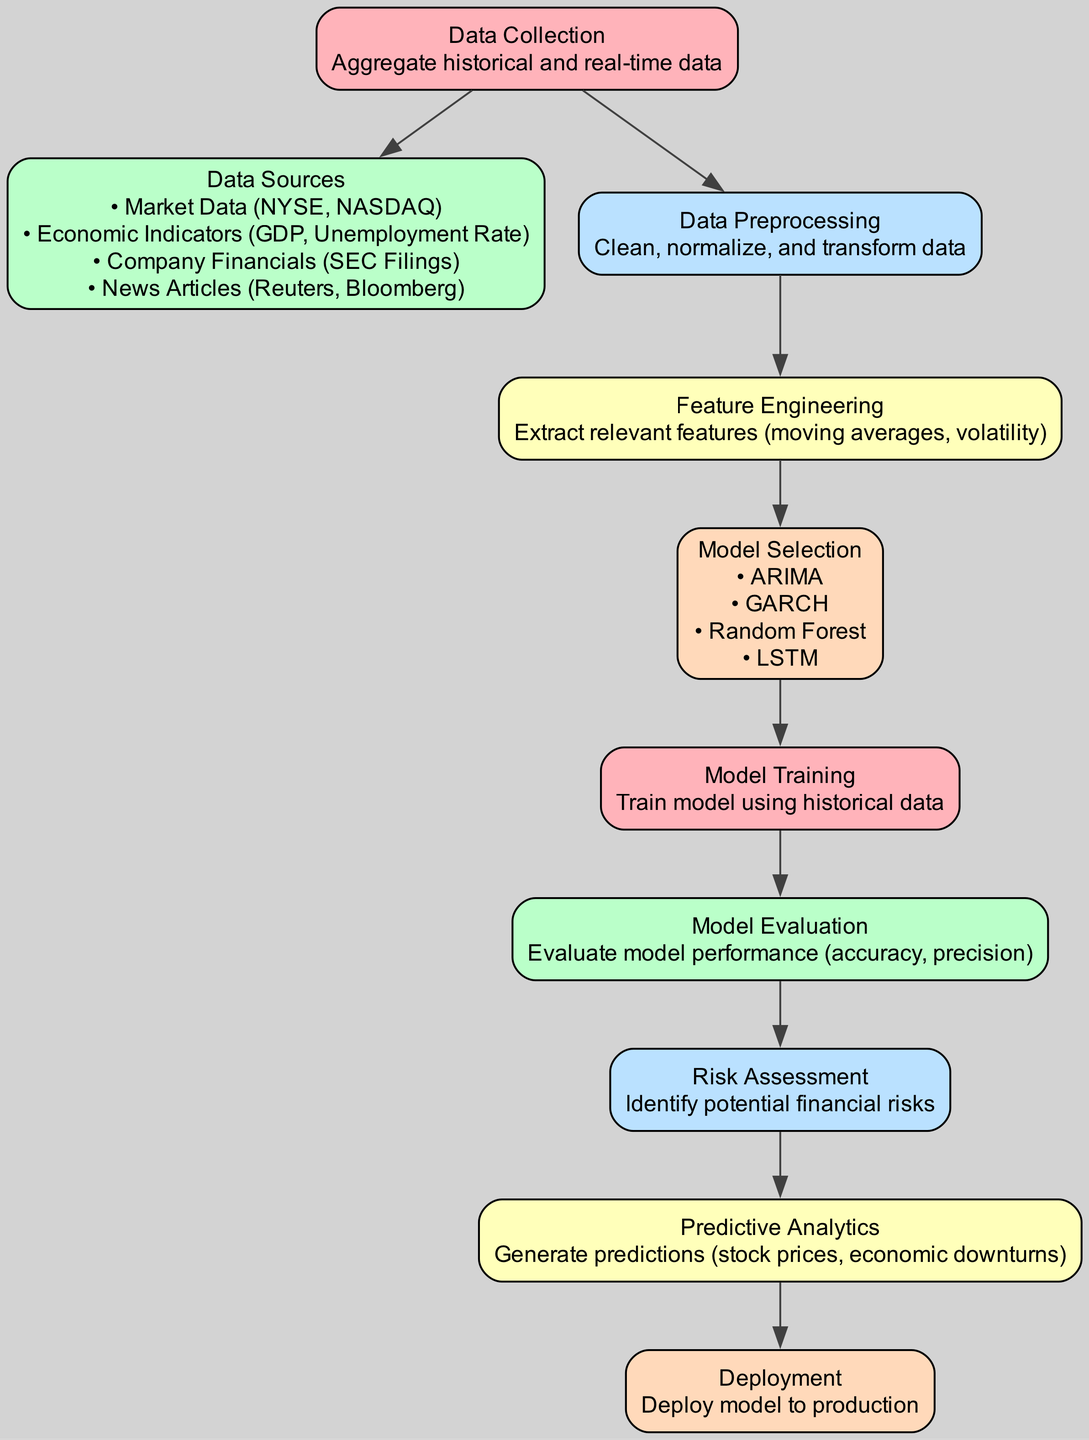What is the first step in the predictive analytics process? The diagram indicates that "Data Collection" is the starting node. This is the first step where historical and real-time data is aggregated.
Answer: Data Collection How many edges are present in the diagram? The diagram shows a total of 9 edges connecting the nodes. Each edge represents a relationship between steps in the predictive analytics process.
Answer: 9 What nodes are linked directly to "Data Preprocessing"? From the diagram, "Data Preprocessing" has direct edges leading to "Feature Engineering" and "Data Collection." This indicates its relationship with both the prior step and the next step.
Answer: Feature Engineering, Data Collection Which model selection techniques are mentioned in the diagram? The diagram highlights four model selection techniques: ARIMA, GARCH, Random Forest, and LSTM. These models are essential for making predictions based on the data.
Answer: ARIMA, GARCH, Random Forest, LSTM What is produced as a result of the "Risk Assessment" stage? The diagram shows that "Risk Assessment" leads to "Predictive Analytics." This indicates that the identification of potential financial risks is a precursor to making predictions.
Answer: Predictive Analytics What comes after "Model Evaluation" in the process? According to the diagram, "Risk Assessment" follows "Model Evaluation." This indicates that evaluating the model's performance directly informs the assessment of risk.
Answer: Risk Assessment Which node provides the input for the "Feature Engineering" step? The diagram indicates that "Data Preprocessing" provides the necessary input for "Feature Engineering." This shows the sequential nature of the process where preprocessing steps precede feature extraction.
Answer: Data Preprocessing What is the purpose of "Deployment" in the diagram? "Deployment" is the final step in the diagram, indicating that once predictions are generated, the model must be put into production for practical use.
Answer: Deploy model to production How many types of data sources are identified in the diagram? The diagram specifies four types of data sources: Market Data, Economic Indicators, Company Financials, and News Articles. This categorization is crucial for data collection.
Answer: 4 